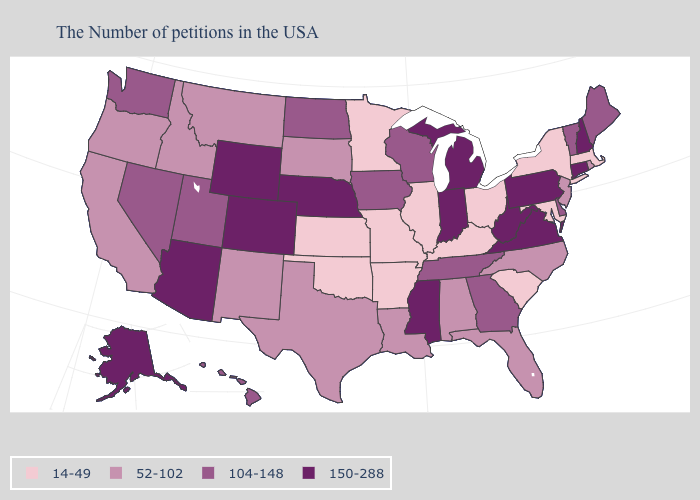Does Louisiana have the lowest value in the USA?
Give a very brief answer. No. What is the value of North Carolina?
Write a very short answer. 52-102. What is the lowest value in states that border Maine?
Answer briefly. 150-288. What is the value of Nevada?
Quick response, please. 104-148. What is the lowest value in the USA?
Concise answer only. 14-49. Name the states that have a value in the range 104-148?
Short answer required. Maine, Vermont, Delaware, Georgia, Tennessee, Wisconsin, Iowa, North Dakota, Utah, Nevada, Washington, Hawaii. What is the lowest value in the USA?
Quick response, please. 14-49. Does the map have missing data?
Quick response, please. No. Among the states that border Virginia , does Maryland have the lowest value?
Give a very brief answer. Yes. What is the value of Illinois?
Short answer required. 14-49. What is the value of Missouri?
Write a very short answer. 14-49. Which states have the highest value in the USA?
Quick response, please. New Hampshire, Connecticut, Pennsylvania, Virginia, West Virginia, Michigan, Indiana, Mississippi, Nebraska, Wyoming, Colorado, Arizona, Alaska. Name the states that have a value in the range 104-148?
Short answer required. Maine, Vermont, Delaware, Georgia, Tennessee, Wisconsin, Iowa, North Dakota, Utah, Nevada, Washington, Hawaii. What is the value of California?
Concise answer only. 52-102. Does Iowa have a lower value than Delaware?
Concise answer only. No. 